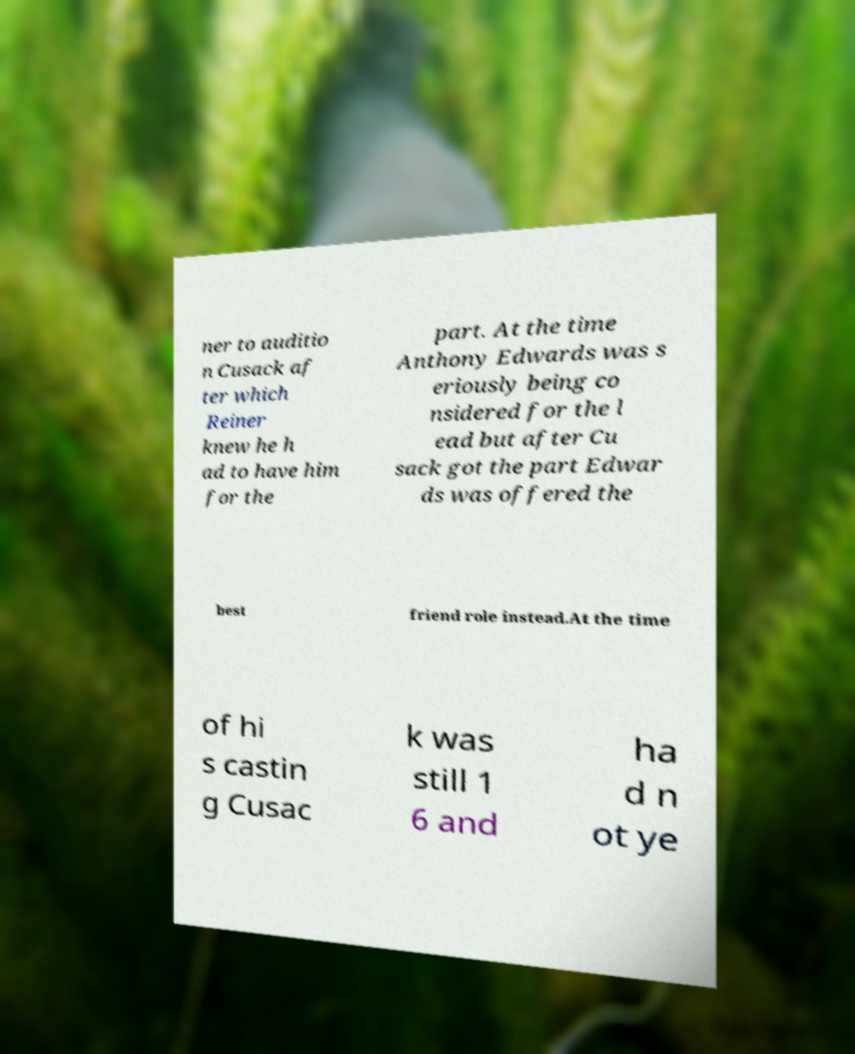Can you read and provide the text displayed in the image?This photo seems to have some interesting text. Can you extract and type it out for me? ner to auditio n Cusack af ter which Reiner knew he h ad to have him for the part. At the time Anthony Edwards was s eriously being co nsidered for the l ead but after Cu sack got the part Edwar ds was offered the best friend role instead.At the time of hi s castin g Cusac k was still 1 6 and ha d n ot ye 